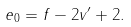<formula> <loc_0><loc_0><loc_500><loc_500>e _ { 0 } = f - 2 v ^ { \prime } + 2 .</formula> 